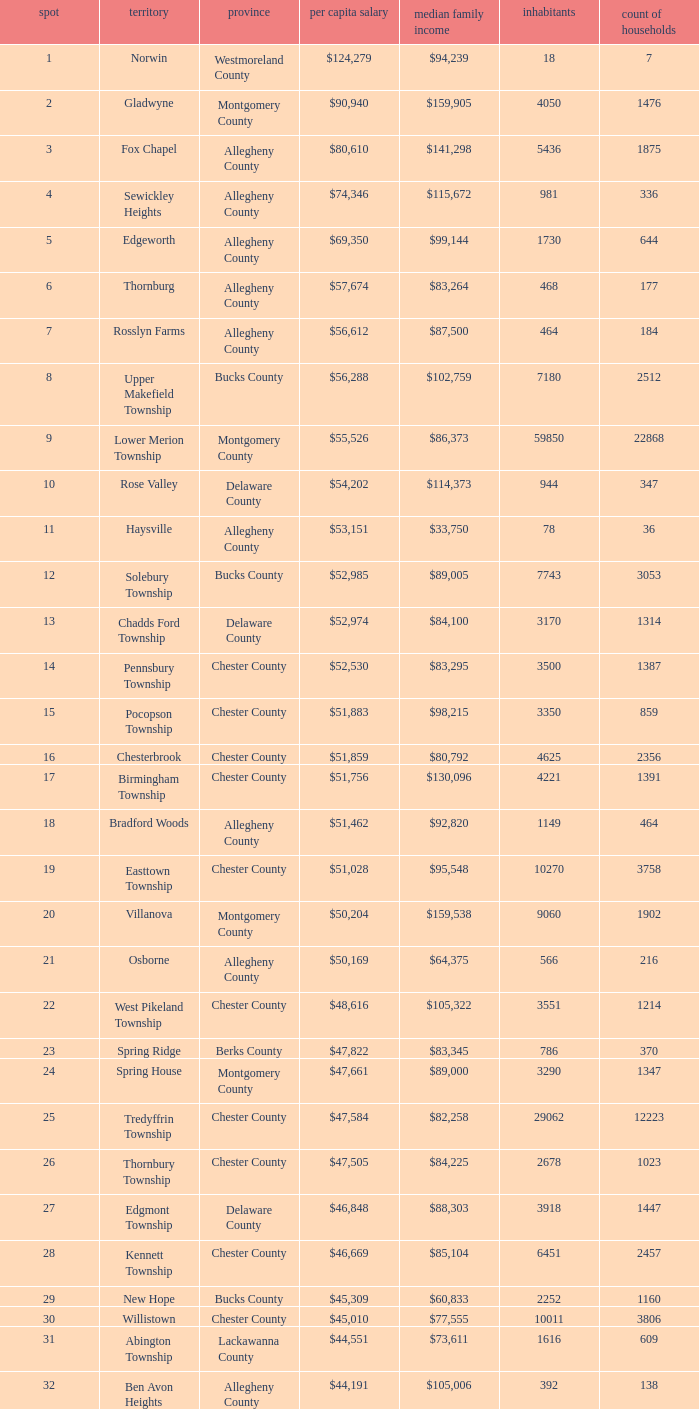What is the per capita income for Fayette County? $42,131. 